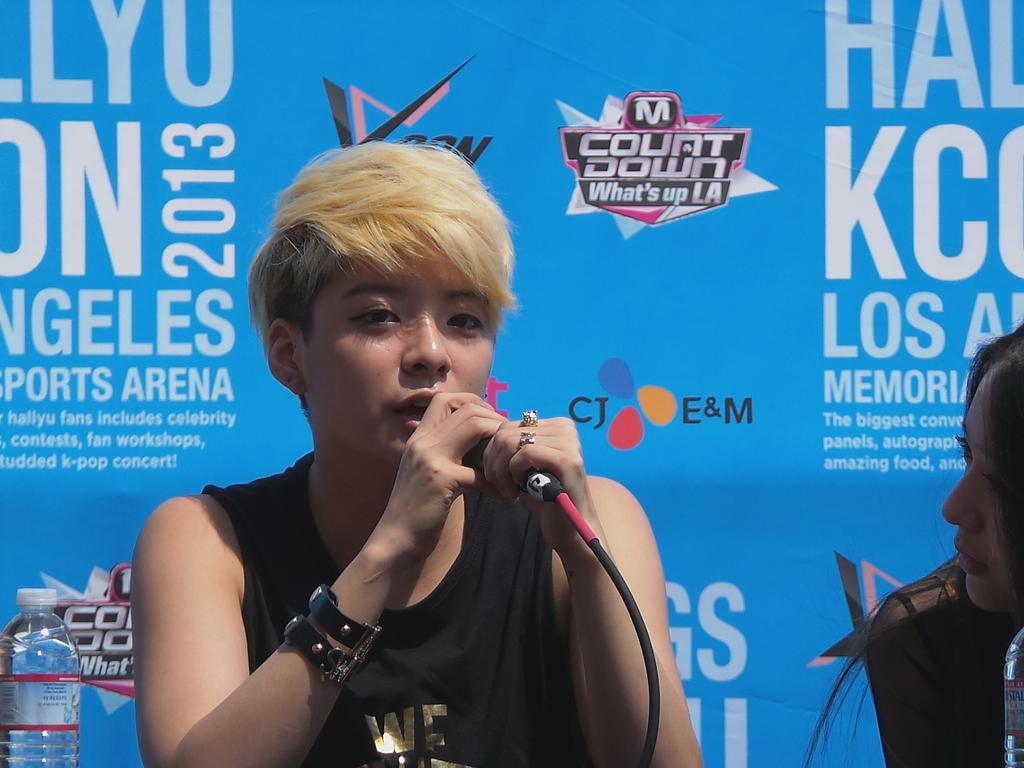What is the person in the image holding? The person is holding a mic in the image. Can you describe any accessories the person is wearing? The person is wearing a wrist band. What is the person doing with the mic? The person is talking. What can be seen in the background of the image? There is a banner in the background of the image. What other object is visible in the image? There is a bottle in the image. Who else is present in the image? There is a lady sitting next to the person holding the mic. Can you tell me how many matches the person is holding in the image? There are no matches present in the image; the person is holding a mic. What type of truck can be seen in the background of the image? There is no truck present in the image; the background features a banner. 